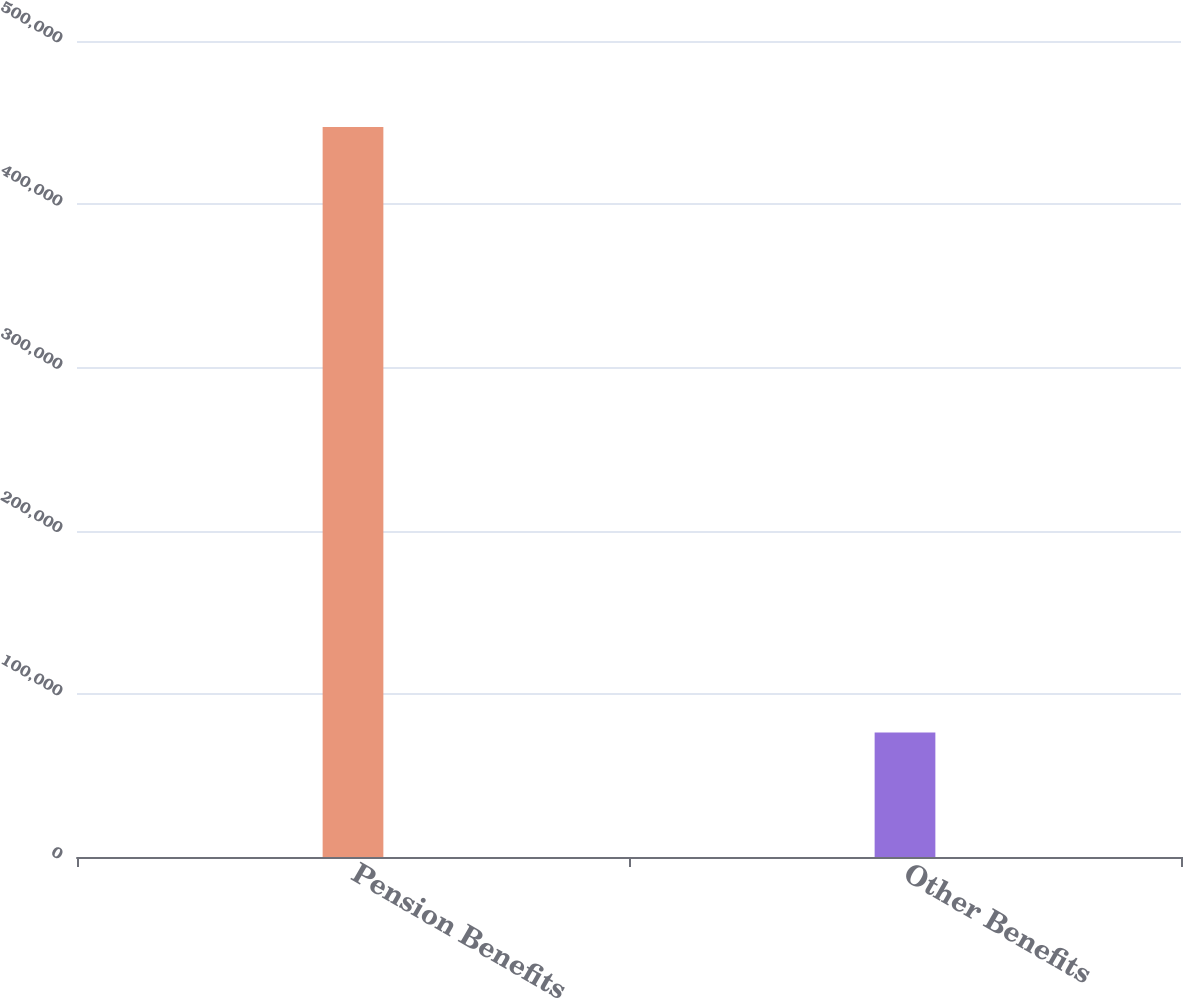Convert chart. <chart><loc_0><loc_0><loc_500><loc_500><bar_chart><fcel>Pension Benefits<fcel>Other Benefits<nl><fcel>447262<fcel>76248<nl></chart> 